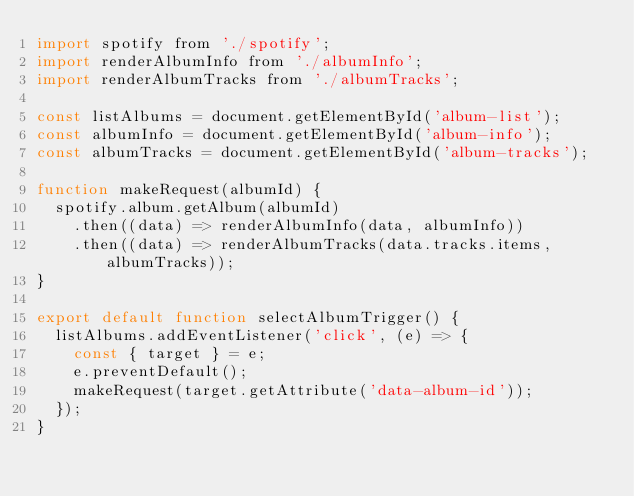Convert code to text. <code><loc_0><loc_0><loc_500><loc_500><_JavaScript_>import spotify from './spotify';
import renderAlbumInfo from './albumInfo';
import renderAlbumTracks from './albumTracks';

const listAlbums = document.getElementById('album-list');
const albumInfo = document.getElementById('album-info');
const albumTracks = document.getElementById('album-tracks');

function makeRequest(albumId) {
  spotify.album.getAlbum(albumId)
    .then((data) => renderAlbumInfo(data, albumInfo))
    .then((data) => renderAlbumTracks(data.tracks.items, albumTracks));
}

export default function selectAlbumTrigger() {
  listAlbums.addEventListener('click', (e) => {
    const { target } = e;
    e.preventDefault();
    makeRequest(target.getAttribute('data-album-id'));
  });
}
</code> 